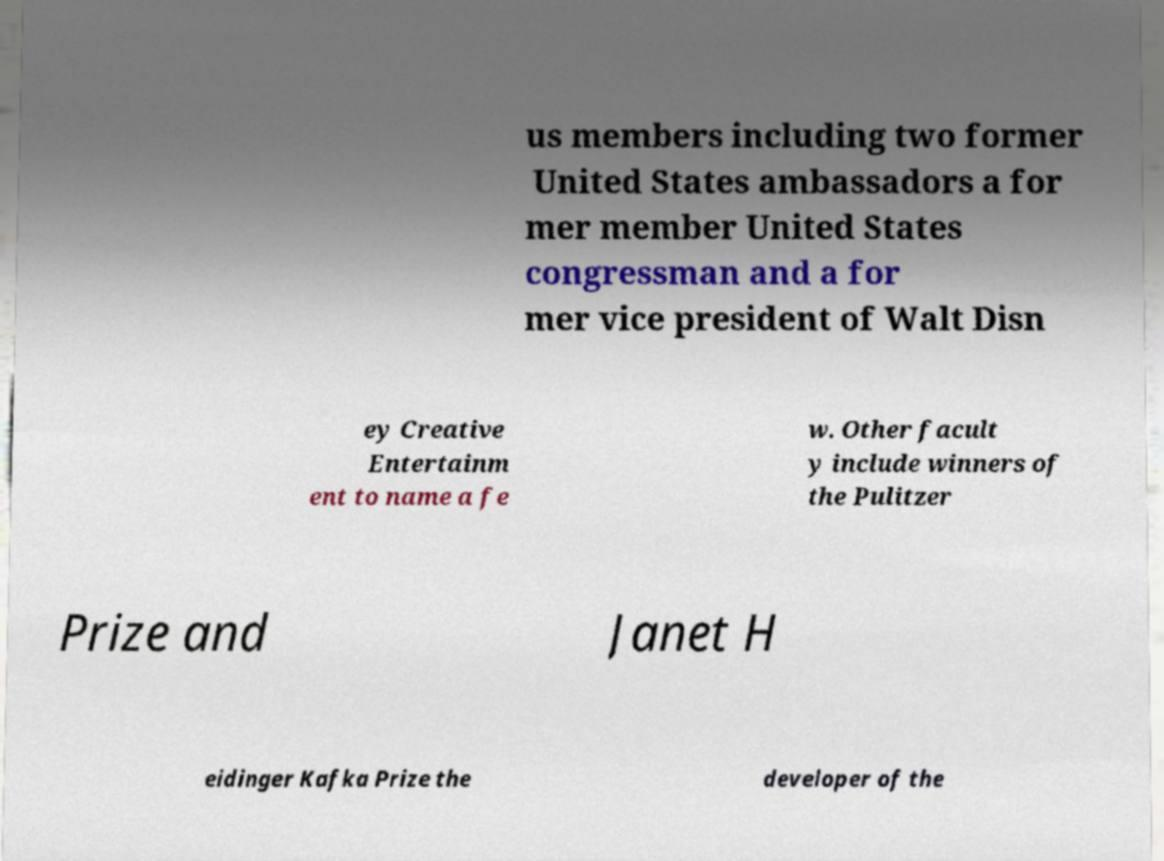There's text embedded in this image that I need extracted. Can you transcribe it verbatim? us members including two former United States ambassadors a for mer member United States congressman and a for mer vice president of Walt Disn ey Creative Entertainm ent to name a fe w. Other facult y include winners of the Pulitzer Prize and Janet H eidinger Kafka Prize the developer of the 